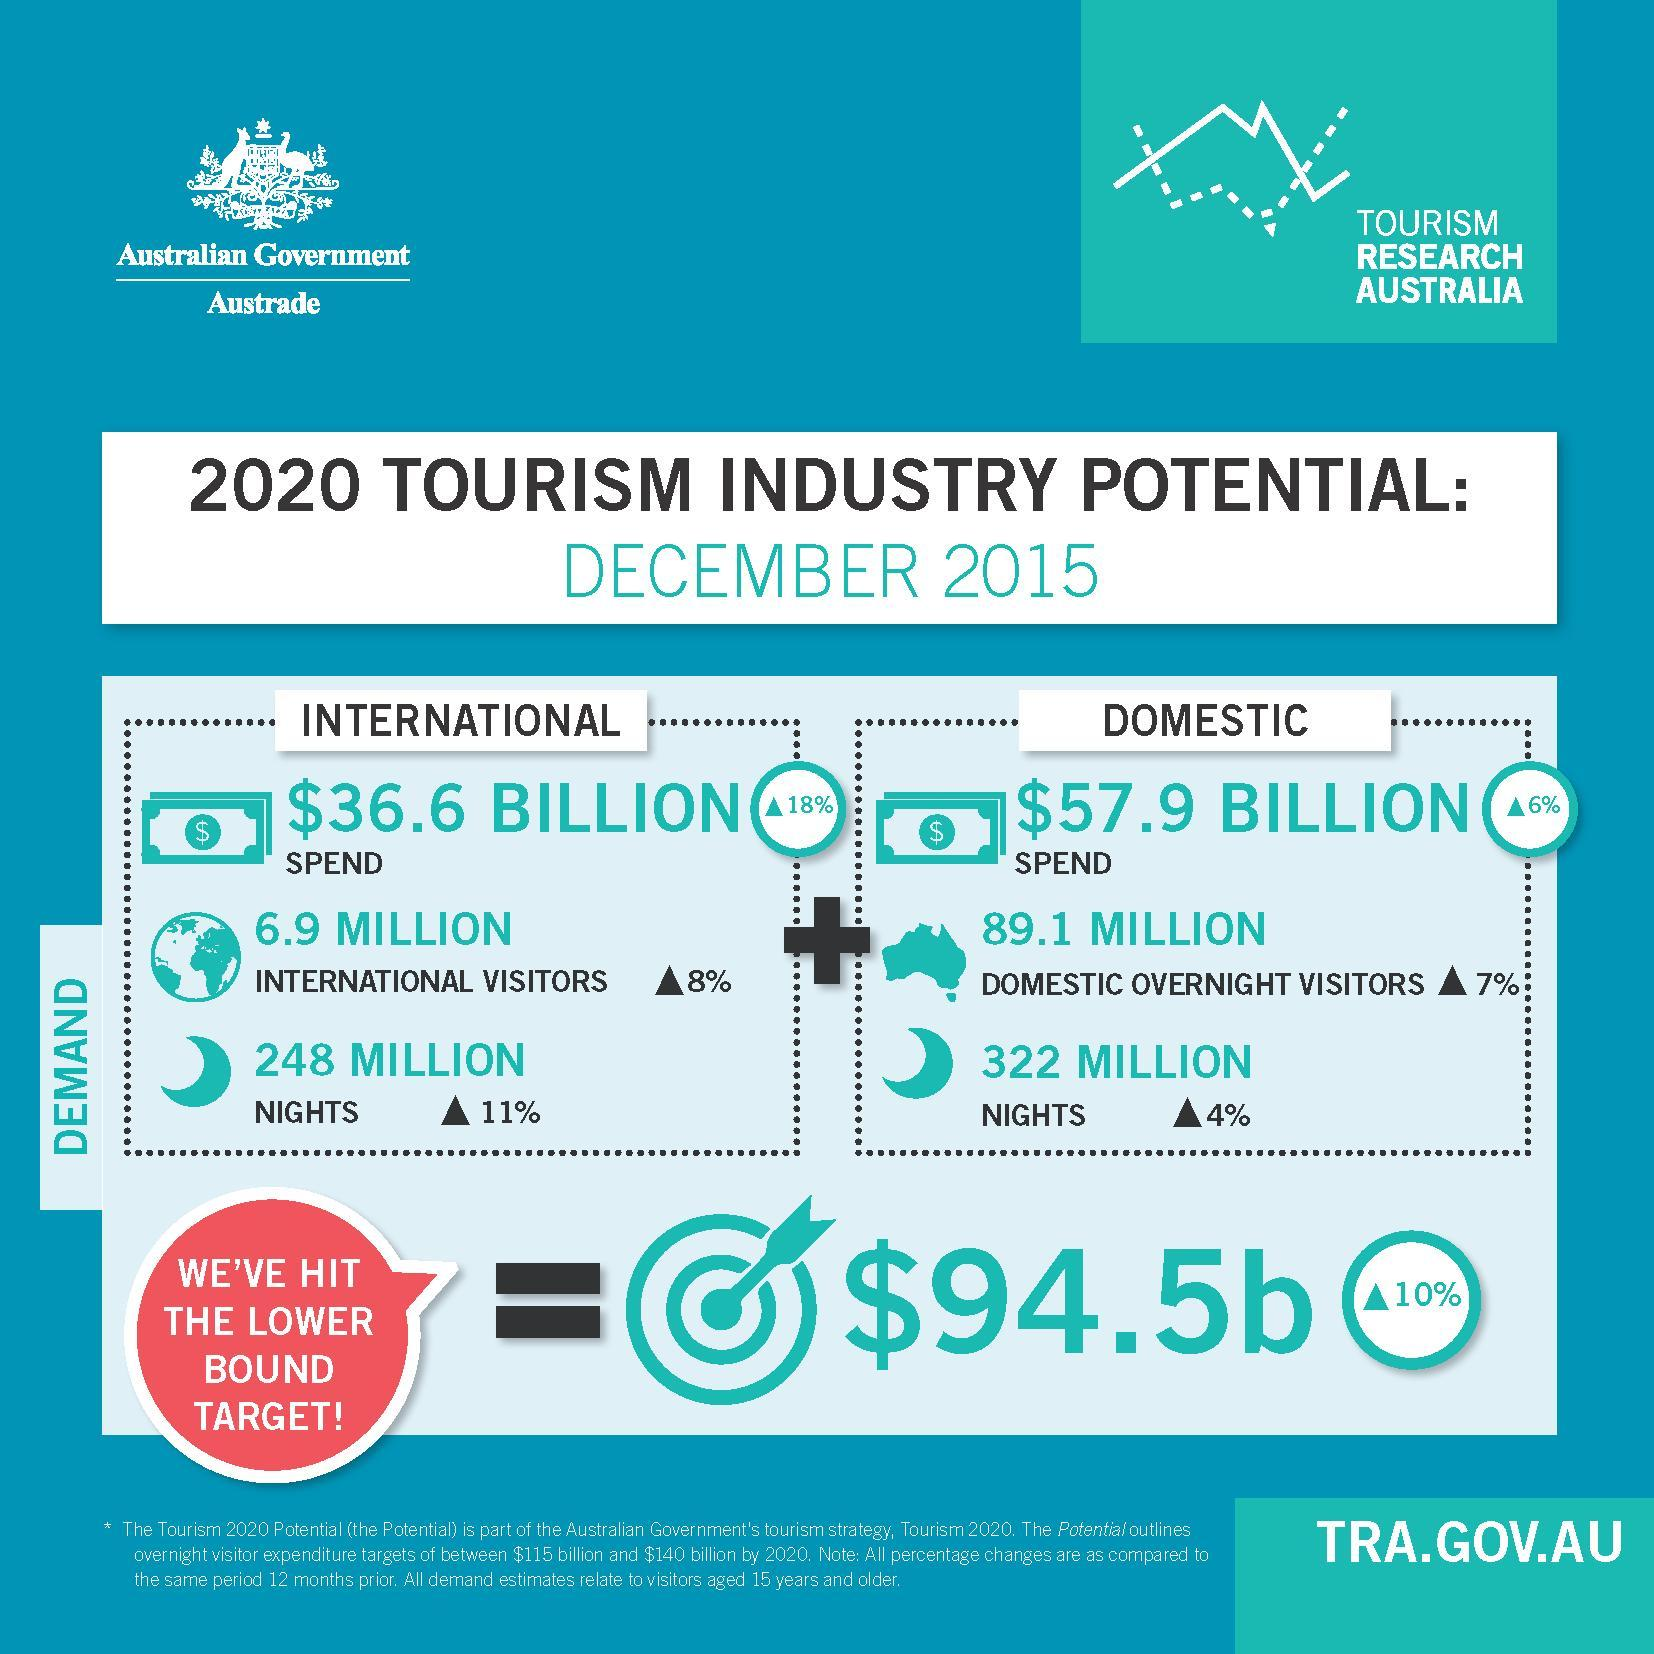By how much million is domestic nights more than international nights
Answer the question with a short phrase. 74 in which year is the report published 2015 what has been the spend on domestic tourism? $57.9 billion what has been the count of domestic overnight visitors 89.1 million in which sector is the spend lower? international in which sector is the spend higher? domestic 